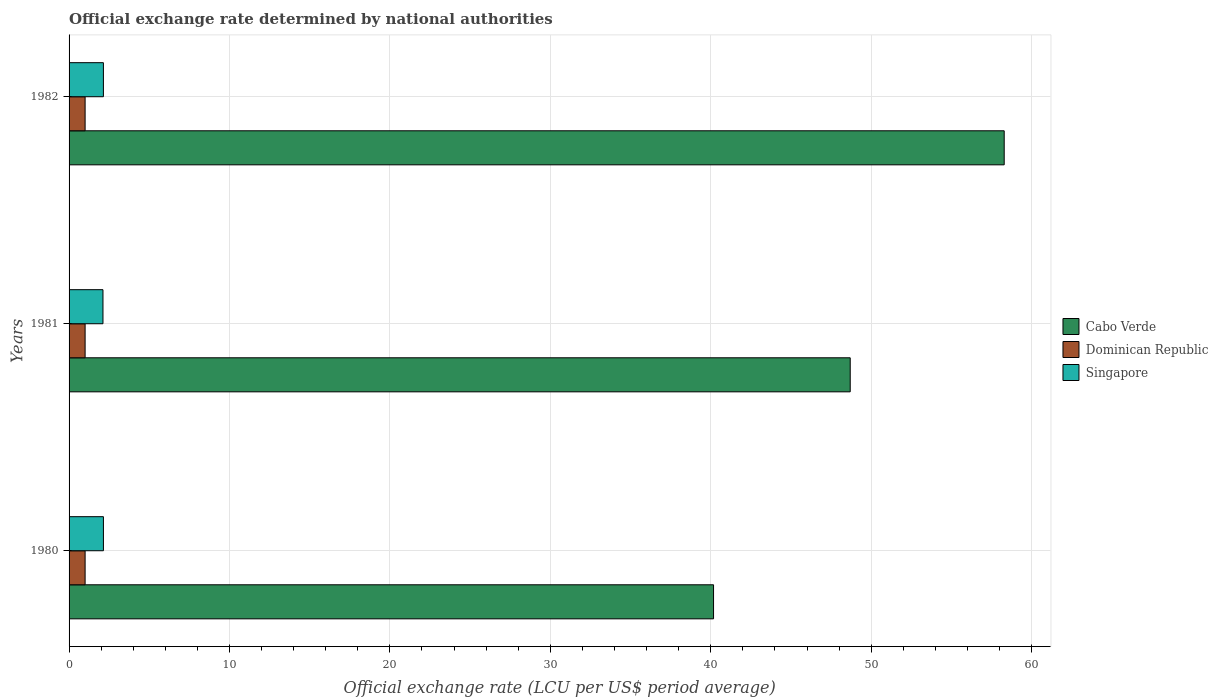Are the number of bars on each tick of the Y-axis equal?
Provide a succinct answer. Yes. In how many cases, is the number of bars for a given year not equal to the number of legend labels?
Your answer should be very brief. 0. What is the official exchange rate in Dominican Republic in 1980?
Your answer should be compact. 1. Across all years, what is the maximum official exchange rate in Singapore?
Provide a short and direct response. 2.14. Across all years, what is the minimum official exchange rate in Singapore?
Offer a terse response. 2.11. What is the total official exchange rate in Dominican Republic in the graph?
Offer a terse response. 3. What is the difference between the official exchange rate in Singapore in 1980 and that in 1981?
Your answer should be very brief. 0.03. What is the difference between the official exchange rate in Singapore in 1981 and the official exchange rate in Dominican Republic in 1980?
Provide a succinct answer. 1.11. What is the average official exchange rate in Cabo Verde per year?
Your answer should be very brief. 49.05. In the year 1982, what is the difference between the official exchange rate in Singapore and official exchange rate in Cabo Verde?
Your answer should be compact. -56.15. In how many years, is the official exchange rate in Cabo Verde greater than 16 LCU?
Keep it short and to the point. 3. What is the ratio of the official exchange rate in Singapore in 1980 to that in 1981?
Ensure brevity in your answer.  1.01. Is the difference between the official exchange rate in Singapore in 1980 and 1982 greater than the difference between the official exchange rate in Cabo Verde in 1980 and 1982?
Provide a short and direct response. Yes. What is the difference between the highest and the lowest official exchange rate in Singapore?
Your response must be concise. 0.03. In how many years, is the official exchange rate in Dominican Republic greater than the average official exchange rate in Dominican Republic taken over all years?
Make the answer very short. 0. Is the sum of the official exchange rate in Dominican Republic in 1980 and 1981 greater than the maximum official exchange rate in Cabo Verde across all years?
Your answer should be very brief. No. What does the 3rd bar from the top in 1981 represents?
Ensure brevity in your answer.  Cabo Verde. What does the 2nd bar from the bottom in 1980 represents?
Provide a short and direct response. Dominican Republic. How many bars are there?
Your answer should be very brief. 9. Are all the bars in the graph horizontal?
Make the answer very short. Yes. What is the difference between two consecutive major ticks on the X-axis?
Give a very brief answer. 10. Are the values on the major ticks of X-axis written in scientific E-notation?
Provide a short and direct response. No. Does the graph contain any zero values?
Your answer should be very brief. No. Does the graph contain grids?
Provide a succinct answer. Yes. How are the legend labels stacked?
Make the answer very short. Vertical. What is the title of the graph?
Keep it short and to the point. Official exchange rate determined by national authorities. Does "Belgium" appear as one of the legend labels in the graph?
Provide a succinct answer. No. What is the label or title of the X-axis?
Your answer should be very brief. Official exchange rate (LCU per US$ period average). What is the label or title of the Y-axis?
Provide a succinct answer. Years. What is the Official exchange rate (LCU per US$ period average) in Cabo Verde in 1980?
Offer a very short reply. 40.17. What is the Official exchange rate (LCU per US$ period average) in Dominican Republic in 1980?
Your answer should be compact. 1. What is the Official exchange rate (LCU per US$ period average) of Singapore in 1980?
Offer a terse response. 2.14. What is the Official exchange rate (LCU per US$ period average) of Cabo Verde in 1981?
Provide a succinct answer. 48.69. What is the Official exchange rate (LCU per US$ period average) of Dominican Republic in 1981?
Provide a short and direct response. 1. What is the Official exchange rate (LCU per US$ period average) of Singapore in 1981?
Ensure brevity in your answer.  2.11. What is the Official exchange rate (LCU per US$ period average) in Cabo Verde in 1982?
Offer a very short reply. 58.29. What is the Official exchange rate (LCU per US$ period average) of Dominican Republic in 1982?
Your response must be concise. 1. What is the Official exchange rate (LCU per US$ period average) in Singapore in 1982?
Your answer should be very brief. 2.14. Across all years, what is the maximum Official exchange rate (LCU per US$ period average) of Cabo Verde?
Your answer should be compact. 58.29. Across all years, what is the maximum Official exchange rate (LCU per US$ period average) in Dominican Republic?
Your answer should be very brief. 1. Across all years, what is the maximum Official exchange rate (LCU per US$ period average) of Singapore?
Provide a succinct answer. 2.14. Across all years, what is the minimum Official exchange rate (LCU per US$ period average) in Cabo Verde?
Provide a succinct answer. 40.17. Across all years, what is the minimum Official exchange rate (LCU per US$ period average) in Dominican Republic?
Provide a succinct answer. 1. Across all years, what is the minimum Official exchange rate (LCU per US$ period average) of Singapore?
Give a very brief answer. 2.11. What is the total Official exchange rate (LCU per US$ period average) of Cabo Verde in the graph?
Make the answer very short. 147.16. What is the total Official exchange rate (LCU per US$ period average) of Dominican Republic in the graph?
Keep it short and to the point. 3. What is the total Official exchange rate (LCU per US$ period average) in Singapore in the graph?
Make the answer very short. 6.39. What is the difference between the Official exchange rate (LCU per US$ period average) in Cabo Verde in 1980 and that in 1981?
Your answer should be compact. -8.52. What is the difference between the Official exchange rate (LCU per US$ period average) in Singapore in 1980 and that in 1981?
Keep it short and to the point. 0.03. What is the difference between the Official exchange rate (LCU per US$ period average) of Cabo Verde in 1980 and that in 1982?
Give a very brief answer. -18.12. What is the difference between the Official exchange rate (LCU per US$ period average) in Singapore in 1980 and that in 1982?
Provide a short and direct response. 0. What is the difference between the Official exchange rate (LCU per US$ period average) of Cabo Verde in 1981 and that in 1982?
Your answer should be compact. -9.6. What is the difference between the Official exchange rate (LCU per US$ period average) of Dominican Republic in 1981 and that in 1982?
Keep it short and to the point. 0. What is the difference between the Official exchange rate (LCU per US$ period average) in Singapore in 1981 and that in 1982?
Ensure brevity in your answer.  -0.03. What is the difference between the Official exchange rate (LCU per US$ period average) in Cabo Verde in 1980 and the Official exchange rate (LCU per US$ period average) in Dominican Republic in 1981?
Your answer should be compact. 39.17. What is the difference between the Official exchange rate (LCU per US$ period average) in Cabo Verde in 1980 and the Official exchange rate (LCU per US$ period average) in Singapore in 1981?
Keep it short and to the point. 38.06. What is the difference between the Official exchange rate (LCU per US$ period average) of Dominican Republic in 1980 and the Official exchange rate (LCU per US$ period average) of Singapore in 1981?
Provide a succinct answer. -1.11. What is the difference between the Official exchange rate (LCU per US$ period average) in Cabo Verde in 1980 and the Official exchange rate (LCU per US$ period average) in Dominican Republic in 1982?
Provide a short and direct response. 39.17. What is the difference between the Official exchange rate (LCU per US$ period average) in Cabo Verde in 1980 and the Official exchange rate (LCU per US$ period average) in Singapore in 1982?
Your response must be concise. 38.03. What is the difference between the Official exchange rate (LCU per US$ period average) of Dominican Republic in 1980 and the Official exchange rate (LCU per US$ period average) of Singapore in 1982?
Your response must be concise. -1.14. What is the difference between the Official exchange rate (LCU per US$ period average) of Cabo Verde in 1981 and the Official exchange rate (LCU per US$ period average) of Dominican Republic in 1982?
Provide a succinct answer. 47.69. What is the difference between the Official exchange rate (LCU per US$ period average) in Cabo Verde in 1981 and the Official exchange rate (LCU per US$ period average) in Singapore in 1982?
Give a very brief answer. 46.55. What is the difference between the Official exchange rate (LCU per US$ period average) in Dominican Republic in 1981 and the Official exchange rate (LCU per US$ period average) in Singapore in 1982?
Your answer should be very brief. -1.14. What is the average Official exchange rate (LCU per US$ period average) in Cabo Verde per year?
Your response must be concise. 49.05. What is the average Official exchange rate (LCU per US$ period average) of Singapore per year?
Your answer should be compact. 2.13. In the year 1980, what is the difference between the Official exchange rate (LCU per US$ period average) in Cabo Verde and Official exchange rate (LCU per US$ period average) in Dominican Republic?
Provide a short and direct response. 39.17. In the year 1980, what is the difference between the Official exchange rate (LCU per US$ period average) in Cabo Verde and Official exchange rate (LCU per US$ period average) in Singapore?
Offer a terse response. 38.03. In the year 1980, what is the difference between the Official exchange rate (LCU per US$ period average) in Dominican Republic and Official exchange rate (LCU per US$ period average) in Singapore?
Your answer should be compact. -1.14. In the year 1981, what is the difference between the Official exchange rate (LCU per US$ period average) of Cabo Verde and Official exchange rate (LCU per US$ period average) of Dominican Republic?
Offer a terse response. 47.69. In the year 1981, what is the difference between the Official exchange rate (LCU per US$ period average) of Cabo Verde and Official exchange rate (LCU per US$ period average) of Singapore?
Your answer should be very brief. 46.58. In the year 1981, what is the difference between the Official exchange rate (LCU per US$ period average) of Dominican Republic and Official exchange rate (LCU per US$ period average) of Singapore?
Offer a terse response. -1.11. In the year 1982, what is the difference between the Official exchange rate (LCU per US$ period average) in Cabo Verde and Official exchange rate (LCU per US$ period average) in Dominican Republic?
Provide a succinct answer. 57.29. In the year 1982, what is the difference between the Official exchange rate (LCU per US$ period average) in Cabo Verde and Official exchange rate (LCU per US$ period average) in Singapore?
Provide a short and direct response. 56.15. In the year 1982, what is the difference between the Official exchange rate (LCU per US$ period average) in Dominican Republic and Official exchange rate (LCU per US$ period average) in Singapore?
Your response must be concise. -1.14. What is the ratio of the Official exchange rate (LCU per US$ period average) of Cabo Verde in 1980 to that in 1981?
Your answer should be very brief. 0.82. What is the ratio of the Official exchange rate (LCU per US$ period average) in Dominican Republic in 1980 to that in 1981?
Make the answer very short. 1. What is the ratio of the Official exchange rate (LCU per US$ period average) of Singapore in 1980 to that in 1981?
Your answer should be very brief. 1.01. What is the ratio of the Official exchange rate (LCU per US$ period average) of Cabo Verde in 1980 to that in 1982?
Your answer should be compact. 0.69. What is the ratio of the Official exchange rate (LCU per US$ period average) of Cabo Verde in 1981 to that in 1982?
Offer a very short reply. 0.84. What is the ratio of the Official exchange rate (LCU per US$ period average) of Dominican Republic in 1981 to that in 1982?
Your answer should be very brief. 1. What is the ratio of the Official exchange rate (LCU per US$ period average) in Singapore in 1981 to that in 1982?
Keep it short and to the point. 0.99. What is the difference between the highest and the second highest Official exchange rate (LCU per US$ period average) of Cabo Verde?
Ensure brevity in your answer.  9.6. What is the difference between the highest and the second highest Official exchange rate (LCU per US$ period average) of Singapore?
Offer a very short reply. 0. What is the difference between the highest and the lowest Official exchange rate (LCU per US$ period average) in Cabo Verde?
Keep it short and to the point. 18.12. What is the difference between the highest and the lowest Official exchange rate (LCU per US$ period average) in Dominican Republic?
Provide a short and direct response. 0. What is the difference between the highest and the lowest Official exchange rate (LCU per US$ period average) in Singapore?
Your answer should be very brief. 0.03. 